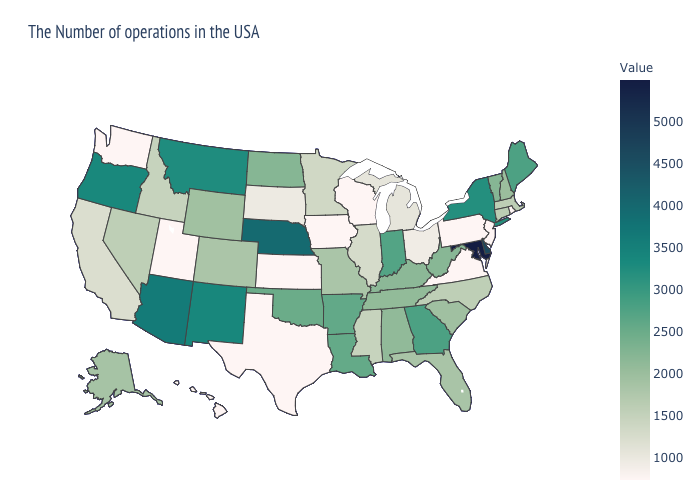Which states have the highest value in the USA?
Short answer required. Maryland. Which states hav the highest value in the South?
Answer briefly. Maryland. Does New York have the highest value in the Northeast?
Give a very brief answer. Yes. Does New Jersey have the highest value in the Northeast?
Answer briefly. No. 